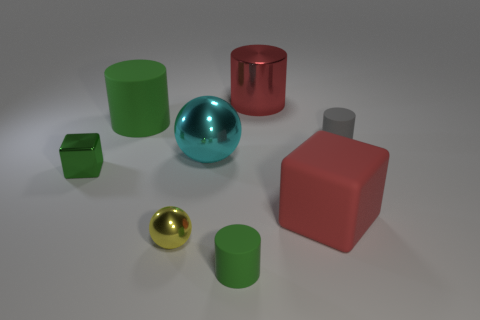How big is the red thing in front of the green matte cylinder that is on the left side of the tiny green matte thing to the left of the tiny gray matte object?
Give a very brief answer. Large. How many other things are the same color as the tiny metal cube?
Ensure brevity in your answer.  2. There is another metal object that is the same size as the cyan thing; what shape is it?
Ensure brevity in your answer.  Cylinder. There is a matte cylinder that is left of the small metal sphere; how big is it?
Your response must be concise. Large. Do the large cylinder on the left side of the shiny cylinder and the matte cylinder that is in front of the gray matte thing have the same color?
Your answer should be compact. Yes. The green thing on the right side of the matte cylinder that is to the left of the tiny green cylinder that is in front of the big red rubber thing is made of what material?
Your answer should be very brief. Rubber. Is there a metal object that has the same size as the gray matte thing?
Your answer should be compact. Yes. There is a block that is the same size as the cyan sphere; what is it made of?
Give a very brief answer. Rubber. What shape is the large red rubber object that is on the right side of the yellow sphere?
Your answer should be compact. Cube. Are the red thing on the right side of the metallic cylinder and the red cylinder on the left side of the gray cylinder made of the same material?
Offer a terse response. No. 